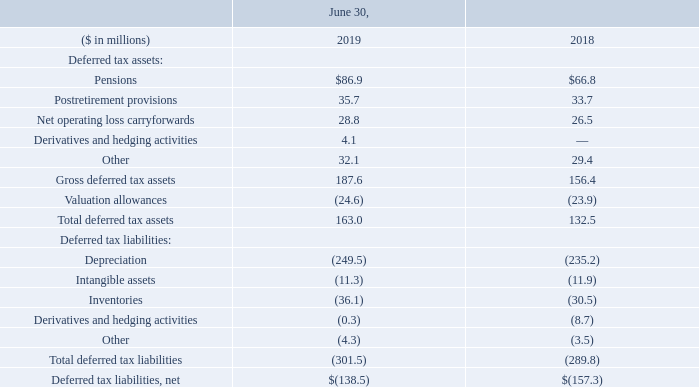Deferred taxes are recorded for temporary differences between the carrying amounts of assets and liabilities and their tax bases. The significant components of deferred tax assets and liabilities that are recorded in the consolidated balance sheets are summarized in the table below. A valuation allowance is required when it is more likely than not that all or a portion of a deferred tax asset will not be realized. As of June 30, 2019, the Company had state net operating loss carryforwards of $337.6 million expiring between 2020 and 2039. A significant portion of the state net operating loss carryforwards are subject to an annual limitation that, under current law, is likely to limit future tax benefits to approximately $3.3 million. Valuation allowances increased by $0.7 million during fiscal year 2019 primarily due to increases in net operating losses incurred in certain tax jurisdictions for which no tax benefit was recognized.
The Company does not have unrecognized tax benefits as of June 30, 2019, 2018 and 2017. The Company
recognizes interest and penalties accrued on any unrecognized tax benefits as a component of income tax expense.
All years prior to fiscal year 2013 have been settled with the Internal Revenue Service and with most significant state, local and foreign tax jurisdictions.
In December 2017, an Act to Provide for Reconciliation Pursuant to Titles II and V of the Concurrent Resolution on the Budget for Fiscal Year 2018 (the “Act”) was enacted. The Act included provisions that reduced the federal statutory income tax rate from 35 percent to 21 percent, created a territorial tax system with a one-time mandatory tax on previously deferred foreign earnings (i.e. transition tax), and changed certain business deductions including allowing for immediate expensing of certain qualified capital expenditures and limitations on deductions of interest expense. The SEC staff issued guidance on income tax accounting for the Act which allowed companies to record provisional amounts during a measurement period not to extend beyond one year of the enactment date. In accordance with this guidance, during fiscal year 2018, we recorded a provisional tax charge of $5.0 million for the transition tax and a provisional tax benefit of $74.6 million for the remeasurement of deferred tax assets and liabilities. During fiscal year 2019, we recorded a discrete tax benefit of $0.2 million in measurement period adjustments for the transition tax offset by a discrete tax charge of $0.2 million for the remeasurement of deferred tax assets and liabilities. Our accounting for the impact of the Act was completed as of the period ending December 31, 2018. Under the Act, the transition tax is being paid over an eight year period beginning in fiscal year 2019.
The Act also established new tax provisions that became effective in fiscal year 2019, including but not limited to eliminating the corporate alternative minimum tax, creating the base erosion anti-abuse tax (“BEAT”), establishing new limitations on deductible interest expense and certain executive compensation, creating a new provision designed to tax global intangible low-tax income (“GILTI”) and generally eliminating U.S. federal income taxes on dividends from foreign subsidiaries. The Company has made an accounting policy election to treat the tax effect of GILTI as a current period expense when incurred.
Undistributed earnings of our foreign subsidiaries, totaling $77.8 million were considered permanently reinvested. Following enactment of the Act, the repatriation of cash to the U.S. is generally no longer taxable for federal income tax purposes. If these earnings were to be repatriated, approximately $0.3 million of tax expense would be incurred.
What was the Postretirement provisions in 2019?
Answer scale should be: million. 35.7. What was the  Net operating loss carryforwards in 2018?
Answer scale should be: million. 26.5. In which years was the amount of deferred tax liabilities, net calculated? 2019, 2018. In which year was the amount of Postretirement provisions larger? 35.7>33.7
Answer: 2019. What was the change in Pensions in 2019 from 2018?
Answer scale should be: million. 86.9-66.8
Answer: 20.1. What was the percentage change in Pensions in 2019 from 2018?
Answer scale should be: percent. (86.9-66.8)/66.8
Answer: 30.09. 